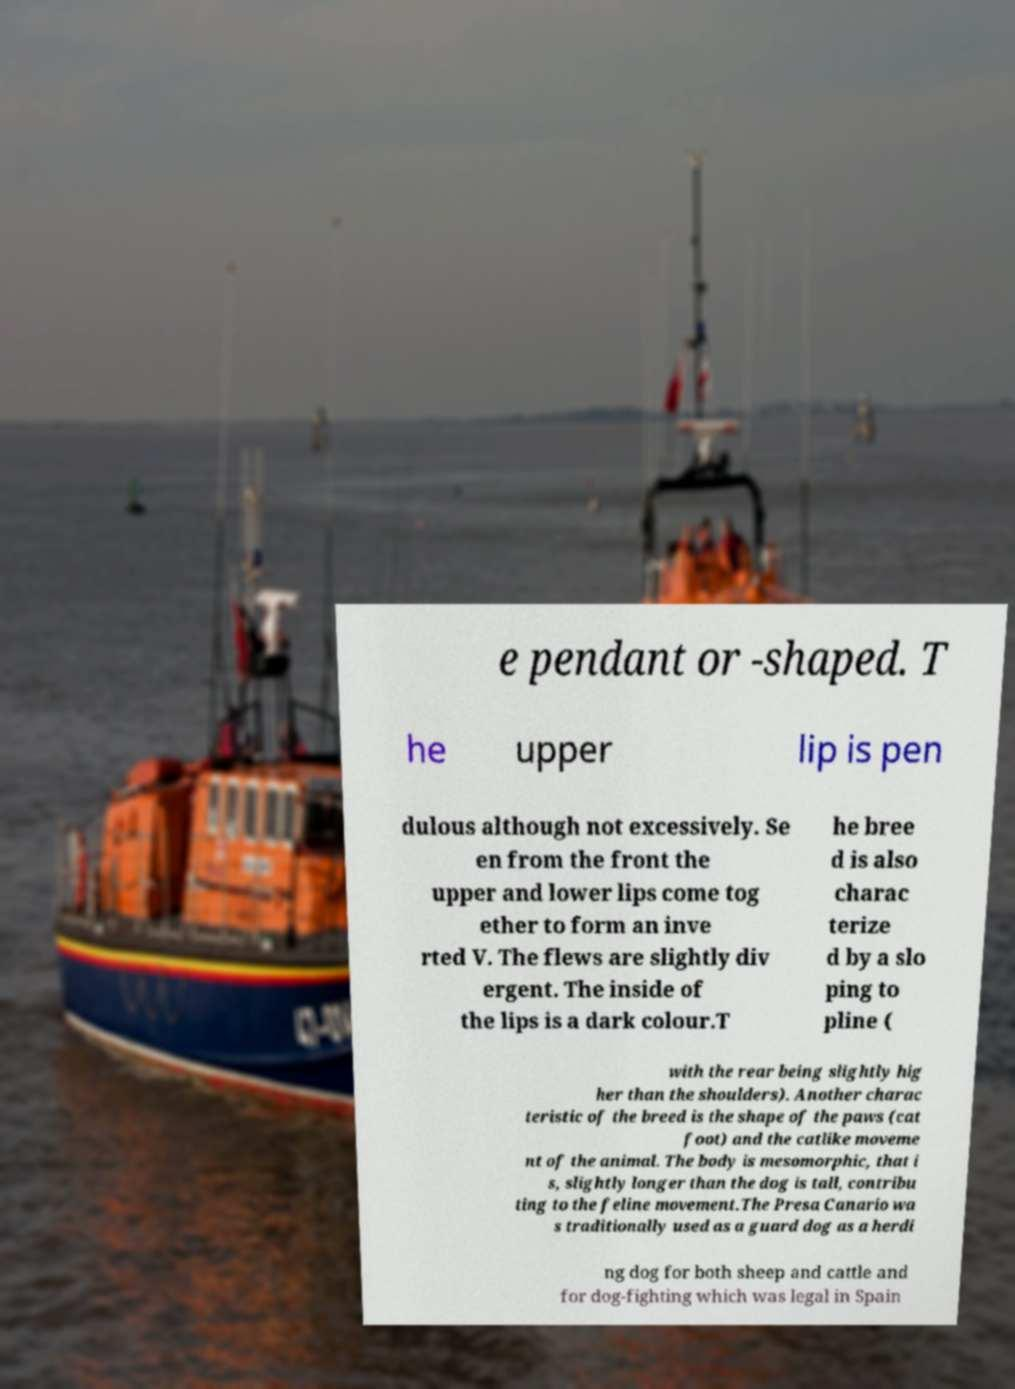I need the written content from this picture converted into text. Can you do that? e pendant or -shaped. T he upper lip is pen dulous although not excessively. Se en from the front the upper and lower lips come tog ether to form an inve rted V. The flews are slightly div ergent. The inside of the lips is a dark colour.T he bree d is also charac terize d by a slo ping to pline ( with the rear being slightly hig her than the shoulders). Another charac teristic of the breed is the shape of the paws (cat foot) and the catlike moveme nt of the animal. The body is mesomorphic, that i s, slightly longer than the dog is tall, contribu ting to the feline movement.The Presa Canario wa s traditionally used as a guard dog as a herdi ng dog for both sheep and cattle and for dog-fighting which was legal in Spain 